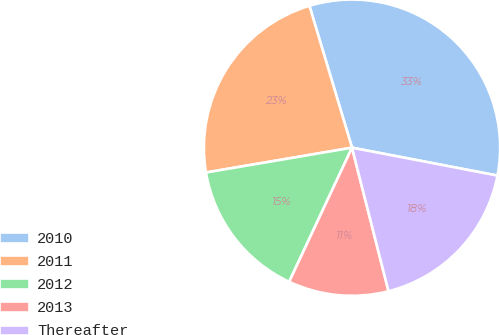<chart> <loc_0><loc_0><loc_500><loc_500><pie_chart><fcel>2010<fcel>2011<fcel>2012<fcel>2013<fcel>Thereafter<nl><fcel>32.66%<fcel>23.04%<fcel>15.34%<fcel>10.94%<fcel>18.02%<nl></chart> 